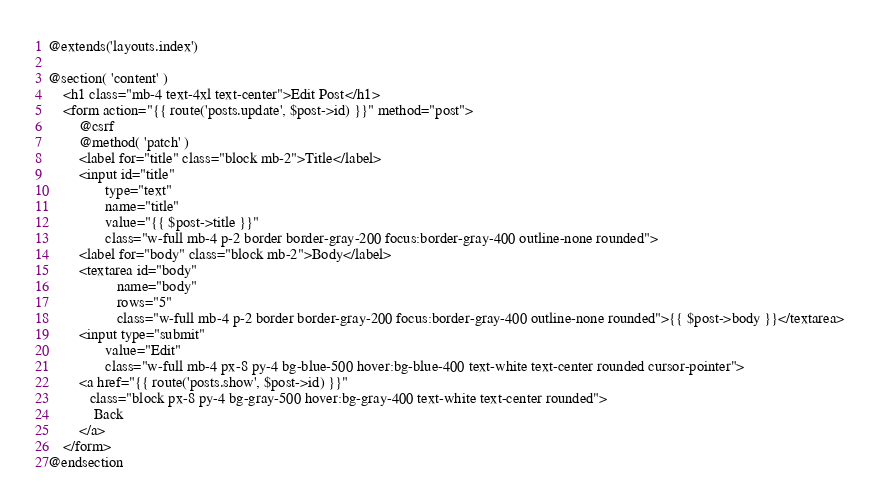Convert code to text. <code><loc_0><loc_0><loc_500><loc_500><_PHP_>@extends('layouts.index')

@section( 'content' )
    <h1 class="mb-4 text-4xl text-center">Edit Post</h1>
    <form action="{{ route('posts.update', $post->id) }}" method="post">
        @csrf
        @method( 'patch' )
        <label for="title" class="block mb-2">Title</label>
        <input id="title"
               type="text"
               name="title"
               value="{{ $post->title }}"
               class="w-full mb-4 p-2 border border-gray-200 focus:border-gray-400 outline-none rounded">
        <label for="body" class="block mb-2">Body</label>
        <textarea id="body"
                  name="body"
                  rows="5"
                  class="w-full mb-4 p-2 border border-gray-200 focus:border-gray-400 outline-none rounded">{{ $post->body }}</textarea>
        <input type="submit"
               value="Edit"
               class="w-full mb-4 px-8 py-4 bg-blue-500 hover:bg-blue-400 text-white text-center rounded cursor-pointer">
        <a href="{{ route('posts.show', $post->id) }}"
           class="block px-8 py-4 bg-gray-500 hover:bg-gray-400 text-white text-center rounded">
            Back
        </a>
    </form>
@endsection
</code> 